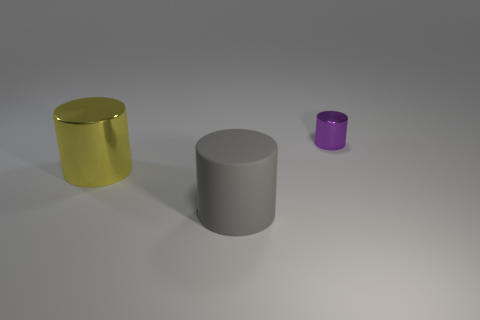Is there any other thing that has the same size as the purple metallic cylinder?
Your response must be concise. No. There is a cylinder that is behind the metal cylinder in front of the tiny purple shiny cylinder; what is its color?
Provide a short and direct response. Purple. Are there fewer purple cylinders in front of the large shiny cylinder than gray objects in front of the tiny thing?
Provide a short and direct response. Yes. What number of things are either things left of the purple object or purple metallic objects?
Offer a terse response. 3. Does the object in front of the yellow object have the same size as the yellow thing?
Offer a very short reply. Yes. Are there fewer large gray rubber objects that are in front of the big matte cylinder than tiny brown objects?
Make the answer very short. No. What material is the yellow cylinder that is the same size as the gray matte thing?
Give a very brief answer. Metal. What number of big things are blue rubber objects or purple objects?
Your answer should be very brief. 0. What number of things are either big things in front of the big yellow thing or tiny shiny objects to the right of the large gray object?
Ensure brevity in your answer.  2. Are there fewer big gray matte objects than tiny purple matte cubes?
Your response must be concise. No. 